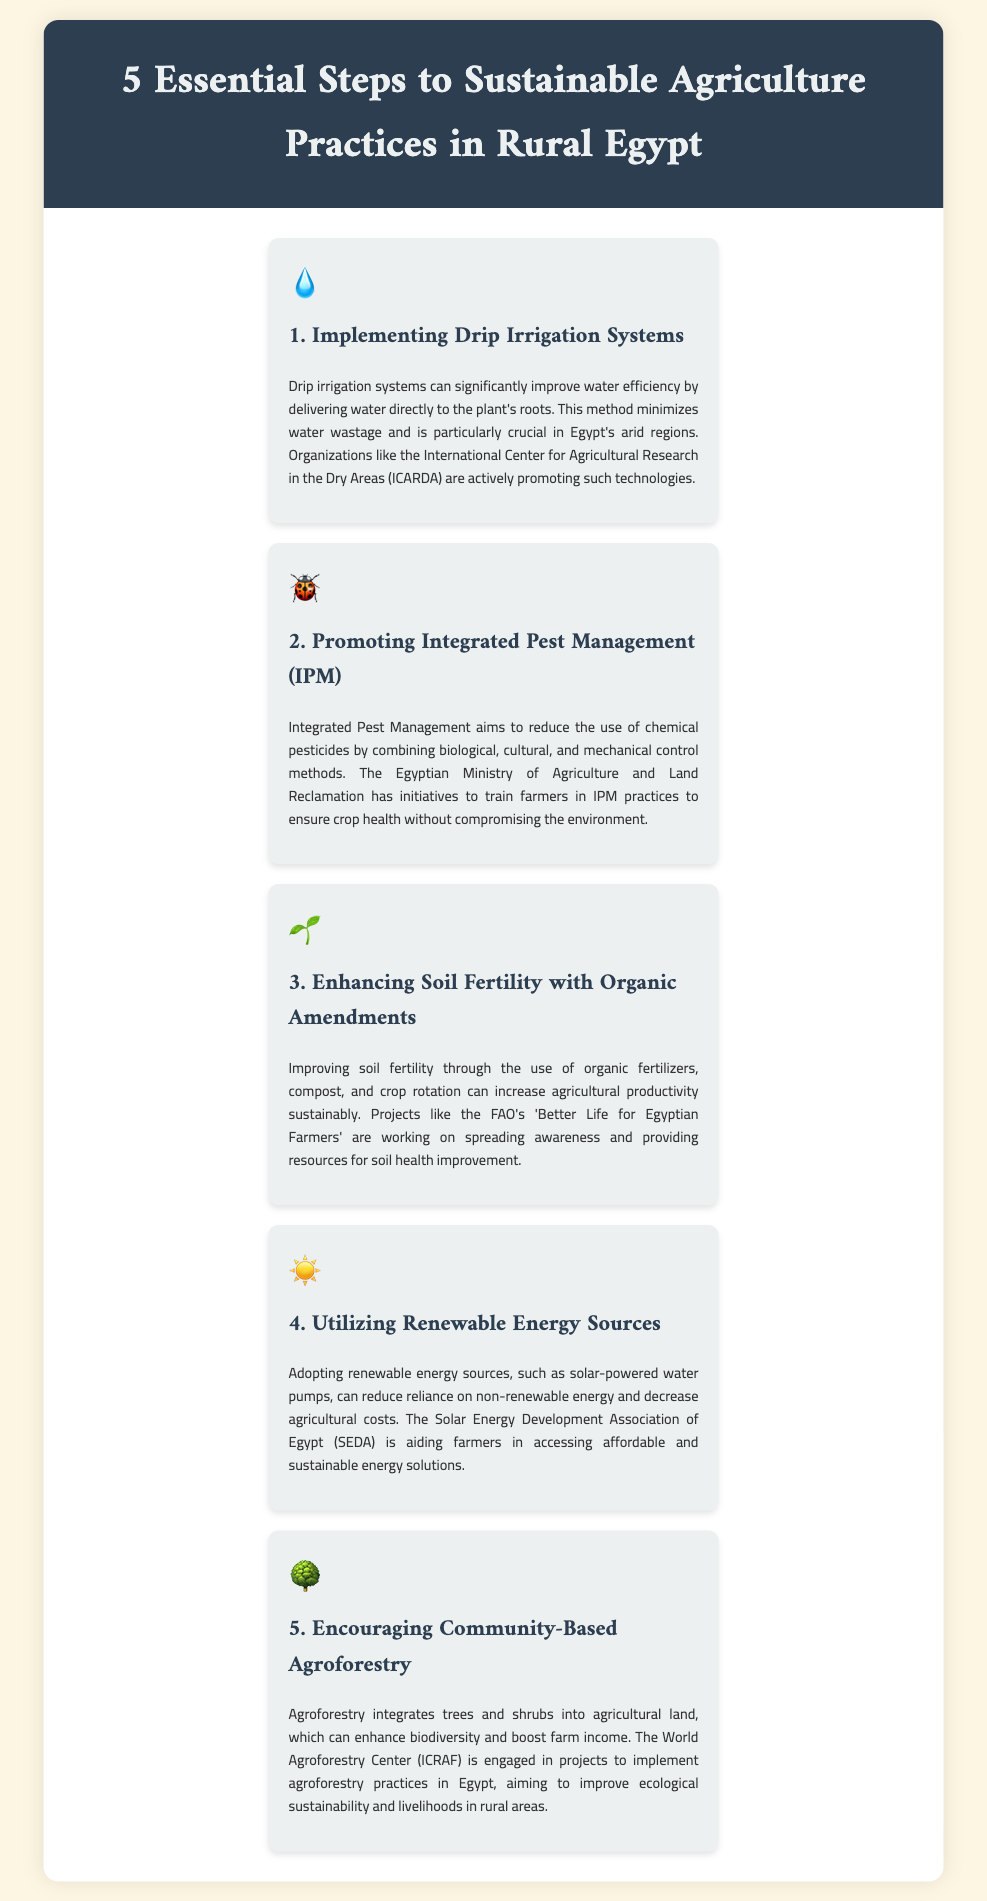what is the first step to sustainable agriculture in rural Egypt? The first step listed is "Implementing Drip Irrigation Systems."
Answer: Implementing Drip Irrigation Systems which organization promotes drip irrigation technologies? The International Center for Agricultural Research in the Dry Areas (ICARDA) is mentioned as promoting drip irrigation.
Answer: ICARDA what is the main goal of Integrated Pest Management (IPM)? The main goal of IPM is to reduce the use of chemical pesticides.
Answer: reduce chemical pesticides who trains farmers in Integrated Pest Management practices? The Egyptian Ministry of Agriculture and Land Reclamation conducts training for farmers in IPM.
Answer: Egyptian Ministry of Agriculture and Land Reclamation what is one method to enhance soil fertility mentioned in the document? The use of organic fertilizers is one method mentioned for enhancing soil fertility.
Answer: organic fertilizers how can farmers reduce reliance on non-renewable energy according to the document? Farmers can reduce reliance by adopting renewable energy sources like solar-powered water pumps.
Answer: renewable energy sources what approach does agroforestry integrate? Agroforestry integrates trees and shrubs into agricultural land.
Answer: trees and shrubs which center is involved in promoting community-based agroforestry in Egypt? The World Agroforestry Center (ICRAF) is mentioned as promoting agroforestry practices.
Answer: World Agroforestry Center (ICRAF) 